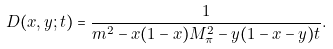Convert formula to latex. <formula><loc_0><loc_0><loc_500><loc_500>D ( x , y ; t ) = \frac { 1 } { m ^ { 2 } - x ( 1 - x ) M _ { \pi } ^ { 2 } - y ( 1 - x - y ) t } .</formula> 